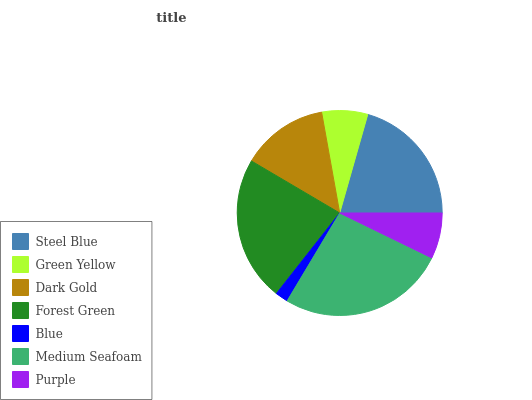Is Blue the minimum?
Answer yes or no. Yes. Is Medium Seafoam the maximum?
Answer yes or no. Yes. Is Green Yellow the minimum?
Answer yes or no. No. Is Green Yellow the maximum?
Answer yes or no. No. Is Steel Blue greater than Green Yellow?
Answer yes or no. Yes. Is Green Yellow less than Steel Blue?
Answer yes or no. Yes. Is Green Yellow greater than Steel Blue?
Answer yes or no. No. Is Steel Blue less than Green Yellow?
Answer yes or no. No. Is Dark Gold the high median?
Answer yes or no. Yes. Is Dark Gold the low median?
Answer yes or no. Yes. Is Purple the high median?
Answer yes or no. No. Is Green Yellow the low median?
Answer yes or no. No. 